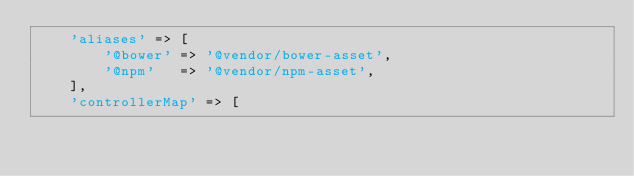Convert code to text. <code><loc_0><loc_0><loc_500><loc_500><_PHP_>    'aliases' => [
        '@bower' => '@vendor/bower-asset',
        '@npm'   => '@vendor/npm-asset',
    ],
    'controllerMap' => [</code> 